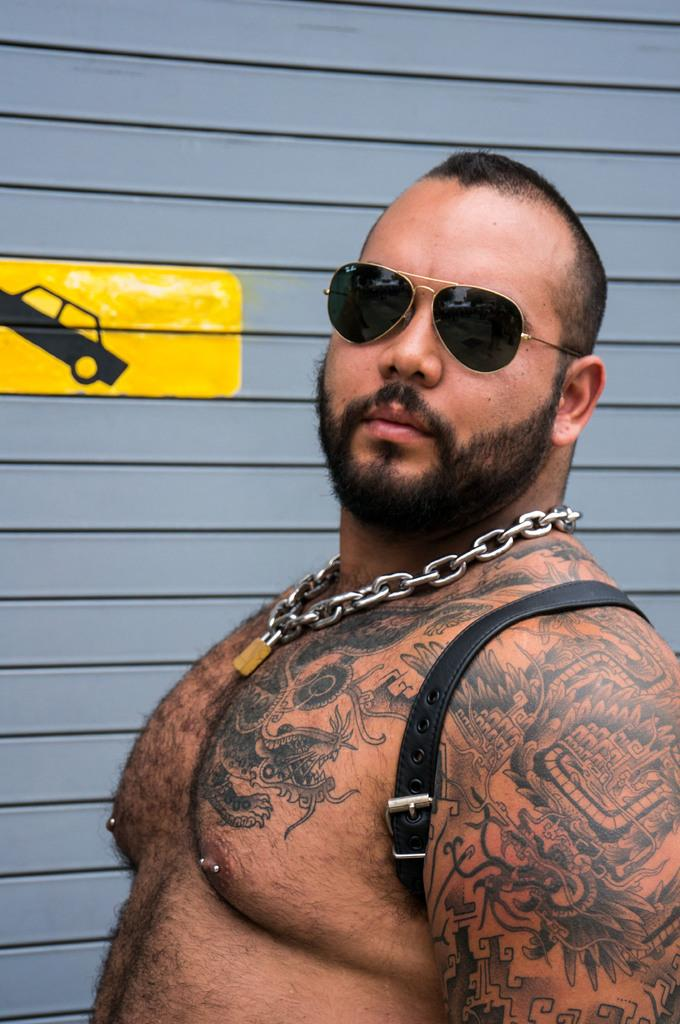What is on the wall in the background of the image? There is a painting on the wall in the background of the image. Who is present in the image? There is a man in the image. What is the man wearing on his face? The man is wearing goggles. What accessory is the man wearing around his neck? The man is wearing a metal chain. What can be seen attached to the man's body? There is a strap visible in the image. What type of body art can be seen on the man? The man has tattoos on his body. What type of debt is the man discussing with the person in the image? There is no indication of a discussion about debt in the image, as the focus is on the man's appearance and the painting in the background. What type of locket is the man wearing around his neck? The man is not wearing a locket in the image; he is wearing a metal chain. 